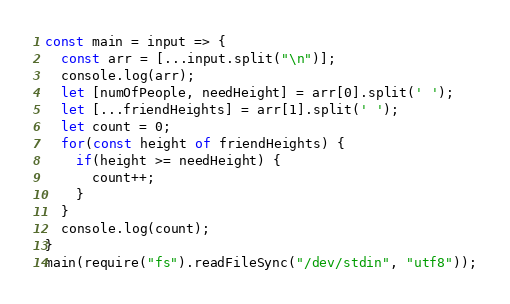<code> <loc_0><loc_0><loc_500><loc_500><_TypeScript_>const main = input => {
  const arr = [...input.split("\n")];
  console.log(arr);
  let [numOfPeople, needHeight] = arr[0].split(' ');
  let [...friendHeights] = arr[1].split(' ');
  let count = 0;
  for(const height of friendHeights) {
    if(height >= needHeight) {
      count++;
    }
  }
  console.log(count);
} 
main(require("fs").readFileSync("/dev/stdin", "utf8"));</code> 